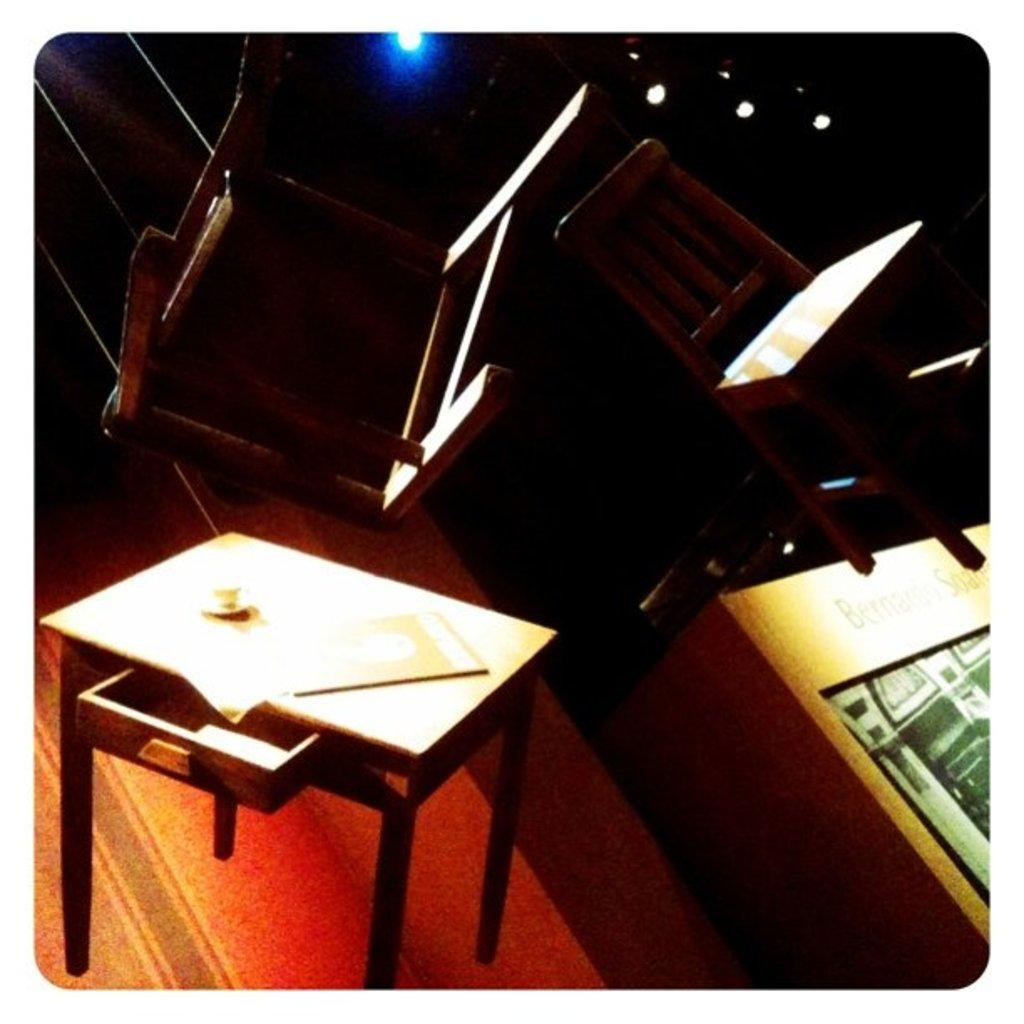What is the color of the background in the image? The background of the image is dark. What can be seen in the image besides the dark background? There are lights, chairs, a table, and other objects in the image. Can you describe the lighting in the image? The lights in the image provide illumination. What type of furniture is present in the image? There are chairs and a table in the image. Is there a notebook on the table in the image? There is no mention of a notebook in the provided facts, so we cannot determine if there is one present in the image. Are there any pests visible in the image? There is no mention of pests in the provided facts, so we cannot determine if there are any present in the image. 